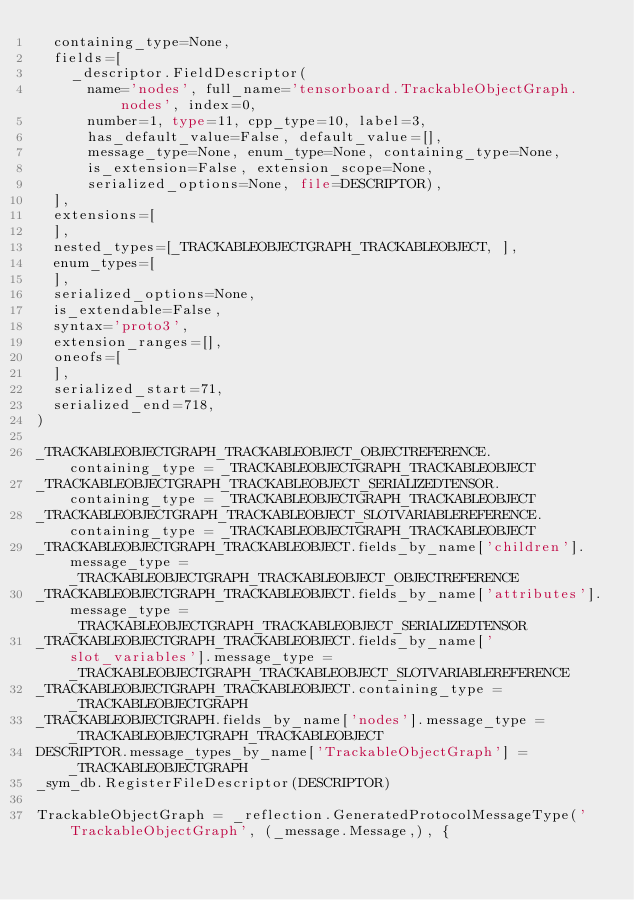<code> <loc_0><loc_0><loc_500><loc_500><_Python_>  containing_type=None,
  fields=[
    _descriptor.FieldDescriptor(
      name='nodes', full_name='tensorboard.TrackableObjectGraph.nodes', index=0,
      number=1, type=11, cpp_type=10, label=3,
      has_default_value=False, default_value=[],
      message_type=None, enum_type=None, containing_type=None,
      is_extension=False, extension_scope=None,
      serialized_options=None, file=DESCRIPTOR),
  ],
  extensions=[
  ],
  nested_types=[_TRACKABLEOBJECTGRAPH_TRACKABLEOBJECT, ],
  enum_types=[
  ],
  serialized_options=None,
  is_extendable=False,
  syntax='proto3',
  extension_ranges=[],
  oneofs=[
  ],
  serialized_start=71,
  serialized_end=718,
)

_TRACKABLEOBJECTGRAPH_TRACKABLEOBJECT_OBJECTREFERENCE.containing_type = _TRACKABLEOBJECTGRAPH_TRACKABLEOBJECT
_TRACKABLEOBJECTGRAPH_TRACKABLEOBJECT_SERIALIZEDTENSOR.containing_type = _TRACKABLEOBJECTGRAPH_TRACKABLEOBJECT
_TRACKABLEOBJECTGRAPH_TRACKABLEOBJECT_SLOTVARIABLEREFERENCE.containing_type = _TRACKABLEOBJECTGRAPH_TRACKABLEOBJECT
_TRACKABLEOBJECTGRAPH_TRACKABLEOBJECT.fields_by_name['children'].message_type = _TRACKABLEOBJECTGRAPH_TRACKABLEOBJECT_OBJECTREFERENCE
_TRACKABLEOBJECTGRAPH_TRACKABLEOBJECT.fields_by_name['attributes'].message_type = _TRACKABLEOBJECTGRAPH_TRACKABLEOBJECT_SERIALIZEDTENSOR
_TRACKABLEOBJECTGRAPH_TRACKABLEOBJECT.fields_by_name['slot_variables'].message_type = _TRACKABLEOBJECTGRAPH_TRACKABLEOBJECT_SLOTVARIABLEREFERENCE
_TRACKABLEOBJECTGRAPH_TRACKABLEOBJECT.containing_type = _TRACKABLEOBJECTGRAPH
_TRACKABLEOBJECTGRAPH.fields_by_name['nodes'].message_type = _TRACKABLEOBJECTGRAPH_TRACKABLEOBJECT
DESCRIPTOR.message_types_by_name['TrackableObjectGraph'] = _TRACKABLEOBJECTGRAPH
_sym_db.RegisterFileDescriptor(DESCRIPTOR)

TrackableObjectGraph = _reflection.GeneratedProtocolMessageType('TrackableObjectGraph', (_message.Message,), {
</code> 